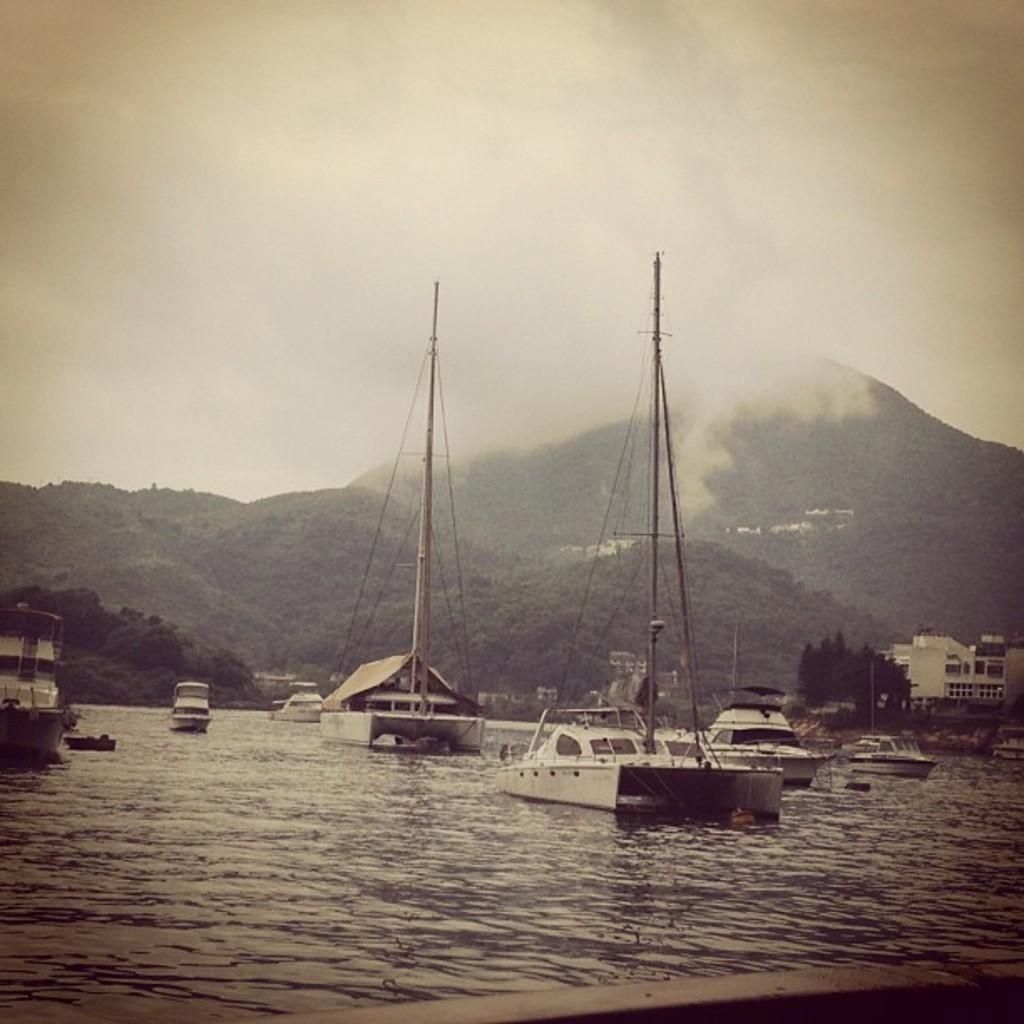What is the primary element in the image? There is water in the image. What type of vehicles are on the water? There are boats with poles on the water. What can be seen on the right side of the image? There is a building and trees on the right side of the image. What is visible in the background of the image? There are hills and the sky visible in the background of the image. What is the condition of the sky in the image? The sky is visible in the background of the image, and there are clouds present. How much credit is available for the boats in the image? There is no mention of credit or financial transactions in the image, so it cannot be determined. Why are the boats crying in the image? There are no boats crying in the image; they are simply floating on the water with their poles. 